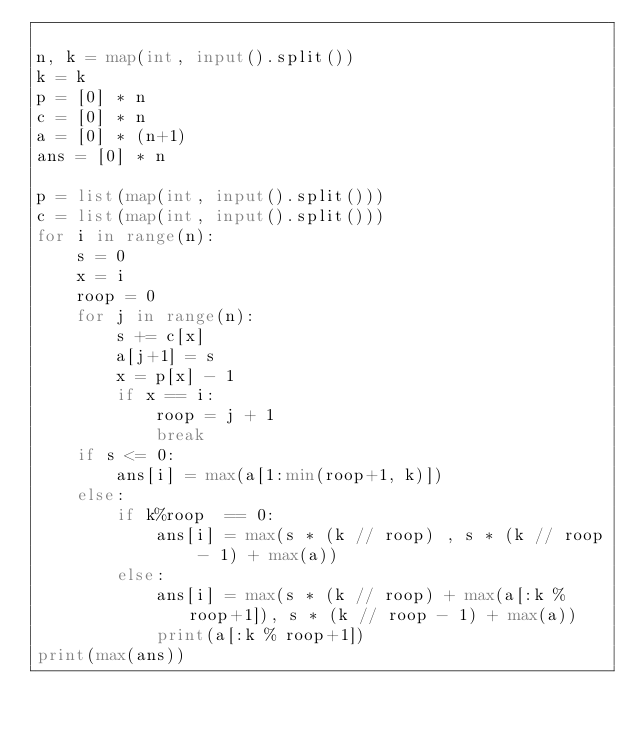Convert code to text. <code><loc_0><loc_0><loc_500><loc_500><_Python_>
n, k = map(int, input().split())
k = k
p = [0] * n
c = [0] * n
a = [0] * (n+1)
ans = [0] * n

p = list(map(int, input().split()))
c = list(map(int, input().split()))
for i in range(n):
    s = 0
    x = i
    roop = 0
    for j in range(n):
        s += c[x]
        a[j+1] = s
        x = p[x] - 1
        if x == i:
            roop = j + 1
            break
    if s <= 0:
        ans[i] = max(a[1:min(roop+1, k)])
    else:
        if k%roop  == 0:
            ans[i] = max(s * (k // roop) , s * (k // roop - 1) + max(a))
        else:
            ans[i] = max(s * (k // roop) + max(a[:k % roop+1]), s * (k // roop - 1) + max(a))
            print(a[:k % roop+1])
print(max(ans))</code> 